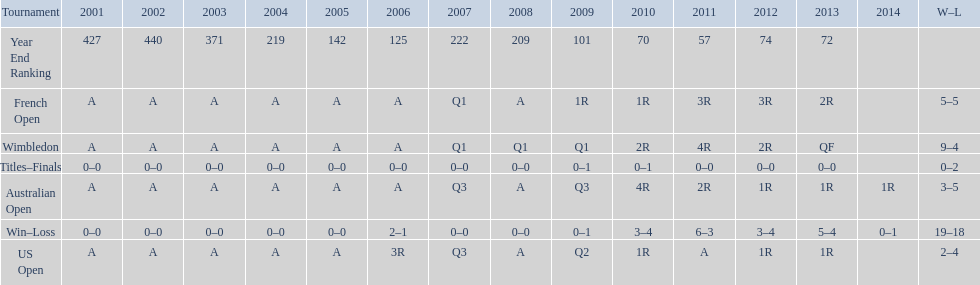In what year was the best year end ranking achieved? 2011. 